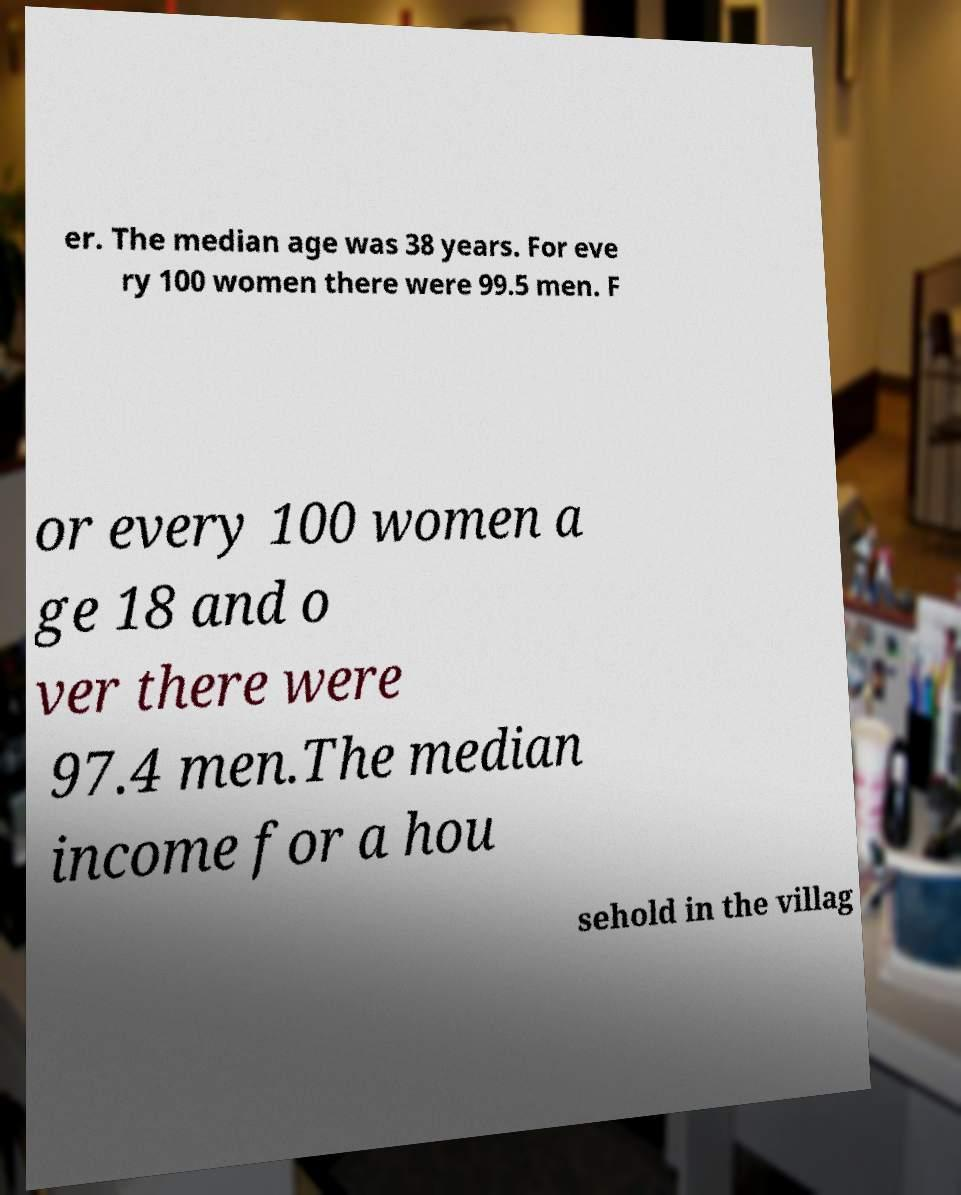What messages or text are displayed in this image? I need them in a readable, typed format. er. The median age was 38 years. For eve ry 100 women there were 99.5 men. F or every 100 women a ge 18 and o ver there were 97.4 men.The median income for a hou sehold in the villag 